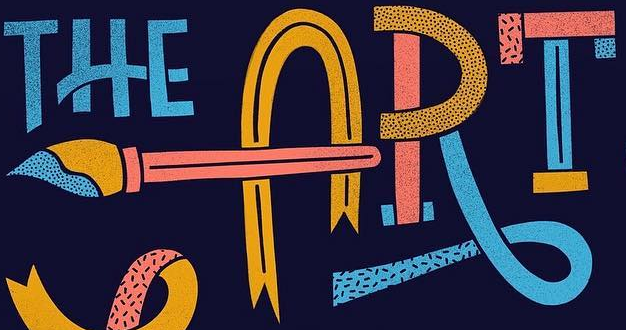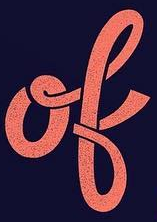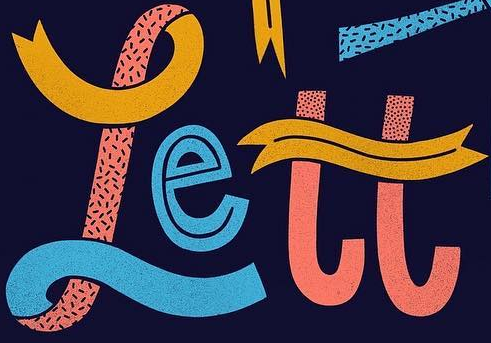What words can you see in these images in sequence, separated by a semicolon? ART; ok; rett 